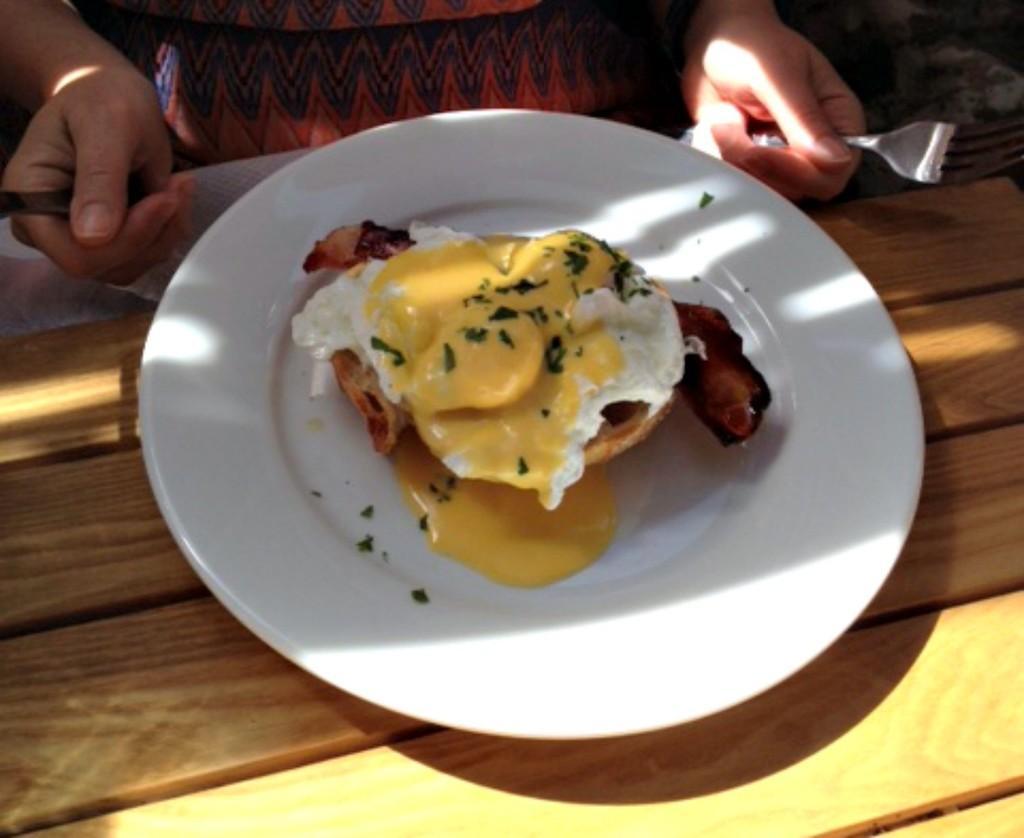Could you give a brief overview of what you see in this image? In this image I can see the plate with food. I can see the plate is in white color and the food is in yellow, white and brown color. The plate is on the brown color surface. In-front of the plate I can see the person holding the fork and an object. 